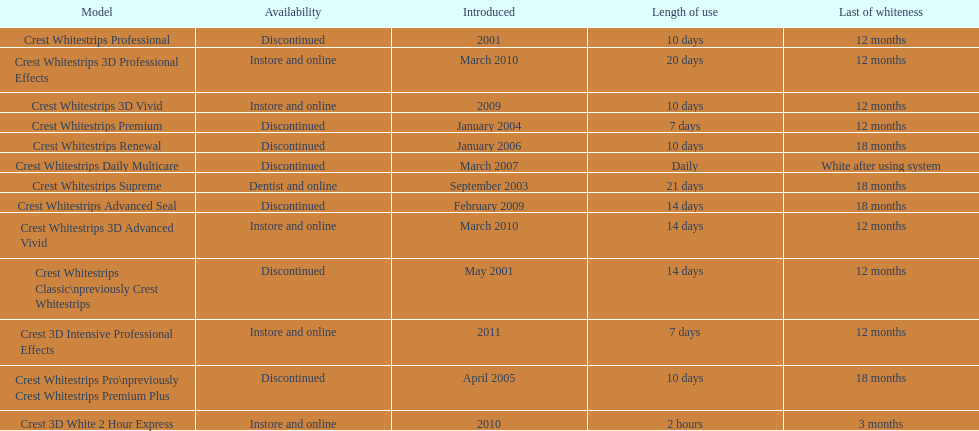Which product was to be used longer, crest whitestrips classic or crest whitestrips 3d vivid? Crest Whitestrips Classic. 